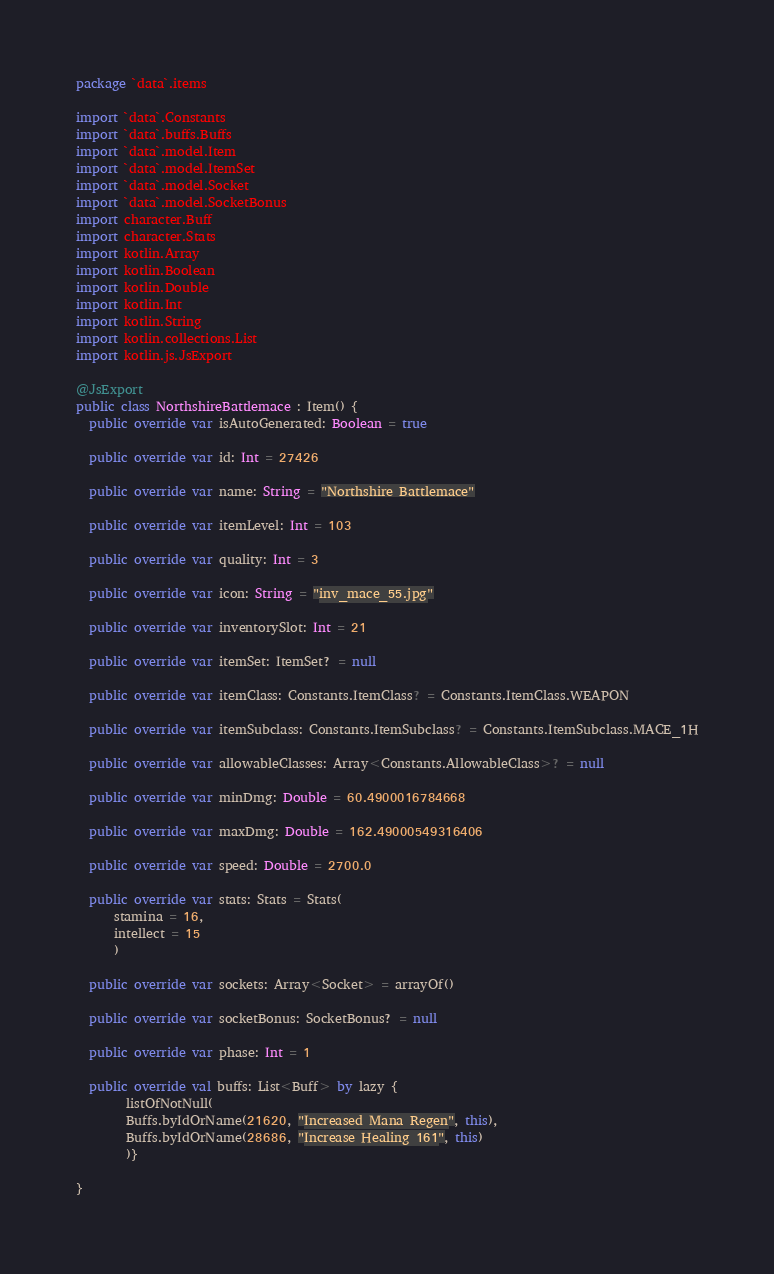Convert code to text. <code><loc_0><loc_0><loc_500><loc_500><_Kotlin_>package `data`.items

import `data`.Constants
import `data`.buffs.Buffs
import `data`.model.Item
import `data`.model.ItemSet
import `data`.model.Socket
import `data`.model.SocketBonus
import character.Buff
import character.Stats
import kotlin.Array
import kotlin.Boolean
import kotlin.Double
import kotlin.Int
import kotlin.String
import kotlin.collections.List
import kotlin.js.JsExport

@JsExport
public class NorthshireBattlemace : Item() {
  public override var isAutoGenerated: Boolean = true

  public override var id: Int = 27426

  public override var name: String = "Northshire Battlemace"

  public override var itemLevel: Int = 103

  public override var quality: Int = 3

  public override var icon: String = "inv_mace_55.jpg"

  public override var inventorySlot: Int = 21

  public override var itemSet: ItemSet? = null

  public override var itemClass: Constants.ItemClass? = Constants.ItemClass.WEAPON

  public override var itemSubclass: Constants.ItemSubclass? = Constants.ItemSubclass.MACE_1H

  public override var allowableClasses: Array<Constants.AllowableClass>? = null

  public override var minDmg: Double = 60.4900016784668

  public override var maxDmg: Double = 162.49000549316406

  public override var speed: Double = 2700.0

  public override var stats: Stats = Stats(
      stamina = 16,
      intellect = 15
      )

  public override var sockets: Array<Socket> = arrayOf()

  public override var socketBonus: SocketBonus? = null

  public override var phase: Int = 1

  public override val buffs: List<Buff> by lazy {
        listOfNotNull(
        Buffs.byIdOrName(21620, "Increased Mana Regen", this),
        Buffs.byIdOrName(28686, "Increase Healing 161", this)
        )}

}
</code> 